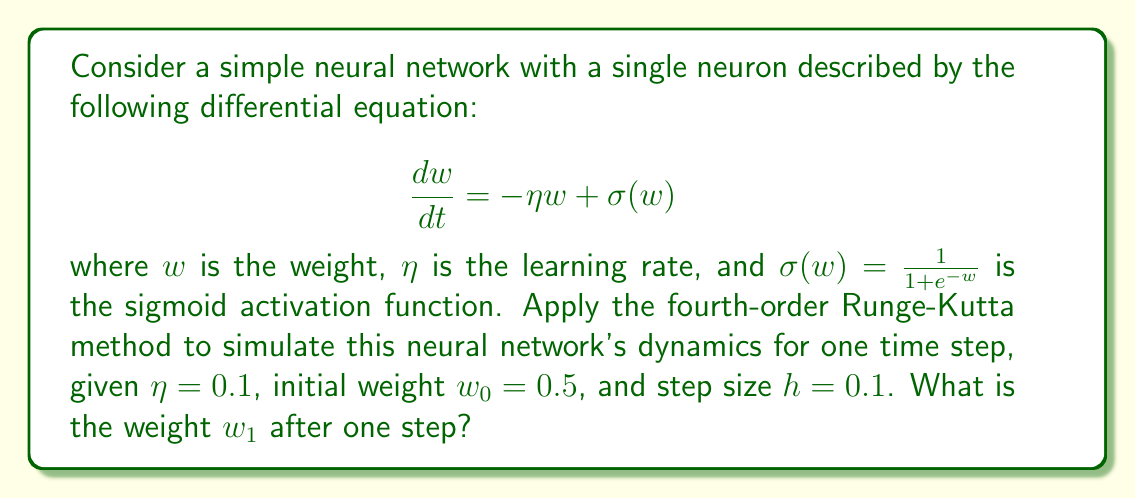Can you solve this math problem? To solve this problem using the fourth-order Runge-Kutta method, we follow these steps:

1. Define the function $f(w, t) = -\eta w + \sigma(w)$

2. Calculate the four Runge-Kutta coefficients:

   $k_1 = hf(w_0, t_0)$
   $k_2 = hf(w_0 + \frac{k_1}{2}, t_0 + \frac{h}{2})$
   $k_3 = hf(w_0 + \frac{k_2}{2}, t_0 + \frac{h}{2})$
   $k_4 = hf(w_0 + k_3, t_0 + h)$

3. Update the weight using the weighted average of the coefficients:

   $w_1 = w_0 + \frac{1}{6}(k_1 + 2k_2 + 2k_3 + k_4)$

Now, let's calculate each step:

1. $f(w, t) = -0.1w + \frac{1}{1+e^{-w}}$

2. Calculate $k_1$:
   $k_1 = 0.1 \cdot (-0.1 \cdot 0.5 + \frac{1}{1+e^{-0.5}}) = 0.01149$

   Calculate $k_2$:
   $w_0 + \frac{k_1}{2} = 0.5 + 0.005745 = 0.505745$
   $k_2 = 0.1 \cdot (-0.1 \cdot 0.505745 + \frac{1}{1+e^{-0.505745}}) = 0.01151$

   Calculate $k_3$:
   $w_0 + \frac{k_2}{2} = 0.5 + 0.005755 = 0.505755$
   $k_3 = 0.1 \cdot (-0.1 \cdot 0.505755 + \frac{1}{1+e^{-0.505755}}) = 0.01151$

   Calculate $k_4$:
   $w_0 + k_3 = 0.5 + 0.01151 = 0.51151$
   $k_4 = 0.1 \cdot (-0.1 \cdot 0.51151 + \frac{1}{1+e^{-0.51151}}) = 0.01153$

3. Update the weight:
   $w_1 = 0.5 + \frac{1}{6}(0.01149 + 2 \cdot 0.01151 + 2 \cdot 0.01151 + 0.01153)$
   $w_1 = 0.5 + 0.01151 = 0.51151$
Answer: $w_1 = 0.51151$ 